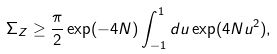<formula> <loc_0><loc_0><loc_500><loc_500>\Sigma _ { Z } & \geq \frac { \pi } { 2 } \exp ( - 4 N ) \int _ { - 1 } ^ { 1 } d u \exp ( 4 N u ^ { 2 } ) ,</formula> 